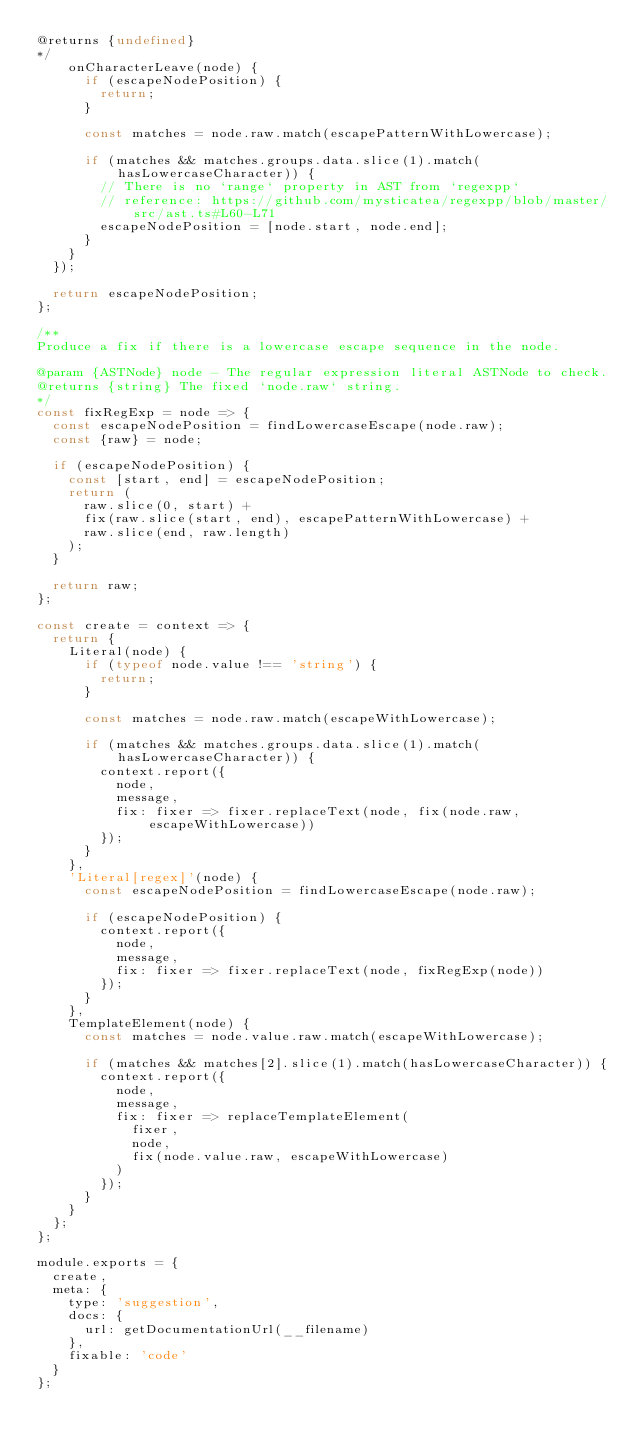<code> <loc_0><loc_0><loc_500><loc_500><_JavaScript_>@returns {undefined}
*/
		onCharacterLeave(node) {
			if (escapeNodePosition) {
				return;
			}

			const matches = node.raw.match(escapePatternWithLowercase);

			if (matches && matches.groups.data.slice(1).match(hasLowercaseCharacter)) {
				// There is no `range` property in AST from `regexpp`
				// reference: https://github.com/mysticatea/regexpp/blob/master/src/ast.ts#L60-L71
				escapeNodePosition = [node.start, node.end];
			}
		}
	});

	return escapeNodePosition;
};

/**
Produce a fix if there is a lowercase escape sequence in the node.

@param {ASTNode} node - The regular expression literal ASTNode to check.
@returns {string} The fixed `node.raw` string.
*/
const fixRegExp = node => {
	const escapeNodePosition = findLowercaseEscape(node.raw);
	const {raw} = node;

	if (escapeNodePosition) {
		const [start, end] = escapeNodePosition;
		return (
			raw.slice(0, start) +
			fix(raw.slice(start, end), escapePatternWithLowercase) +
			raw.slice(end, raw.length)
		);
	}

	return raw;
};

const create = context => {
	return {
		Literal(node) {
			if (typeof node.value !== 'string') {
				return;
			}

			const matches = node.raw.match(escapeWithLowercase);

			if (matches && matches.groups.data.slice(1).match(hasLowercaseCharacter)) {
				context.report({
					node,
					message,
					fix: fixer => fixer.replaceText(node, fix(node.raw, escapeWithLowercase))
				});
			}
		},
		'Literal[regex]'(node) {
			const escapeNodePosition = findLowercaseEscape(node.raw);

			if (escapeNodePosition) {
				context.report({
					node,
					message,
					fix: fixer => fixer.replaceText(node, fixRegExp(node))
				});
			}
		},
		TemplateElement(node) {
			const matches = node.value.raw.match(escapeWithLowercase);

			if (matches && matches[2].slice(1).match(hasLowercaseCharacter)) {
				context.report({
					node,
					message,
					fix: fixer => replaceTemplateElement(
						fixer,
						node,
						fix(node.value.raw, escapeWithLowercase)
					)
				});
			}
		}
	};
};

module.exports = {
	create,
	meta: {
		type: 'suggestion',
		docs: {
			url: getDocumentationUrl(__filename)
		},
		fixable: 'code'
	}
};
</code> 